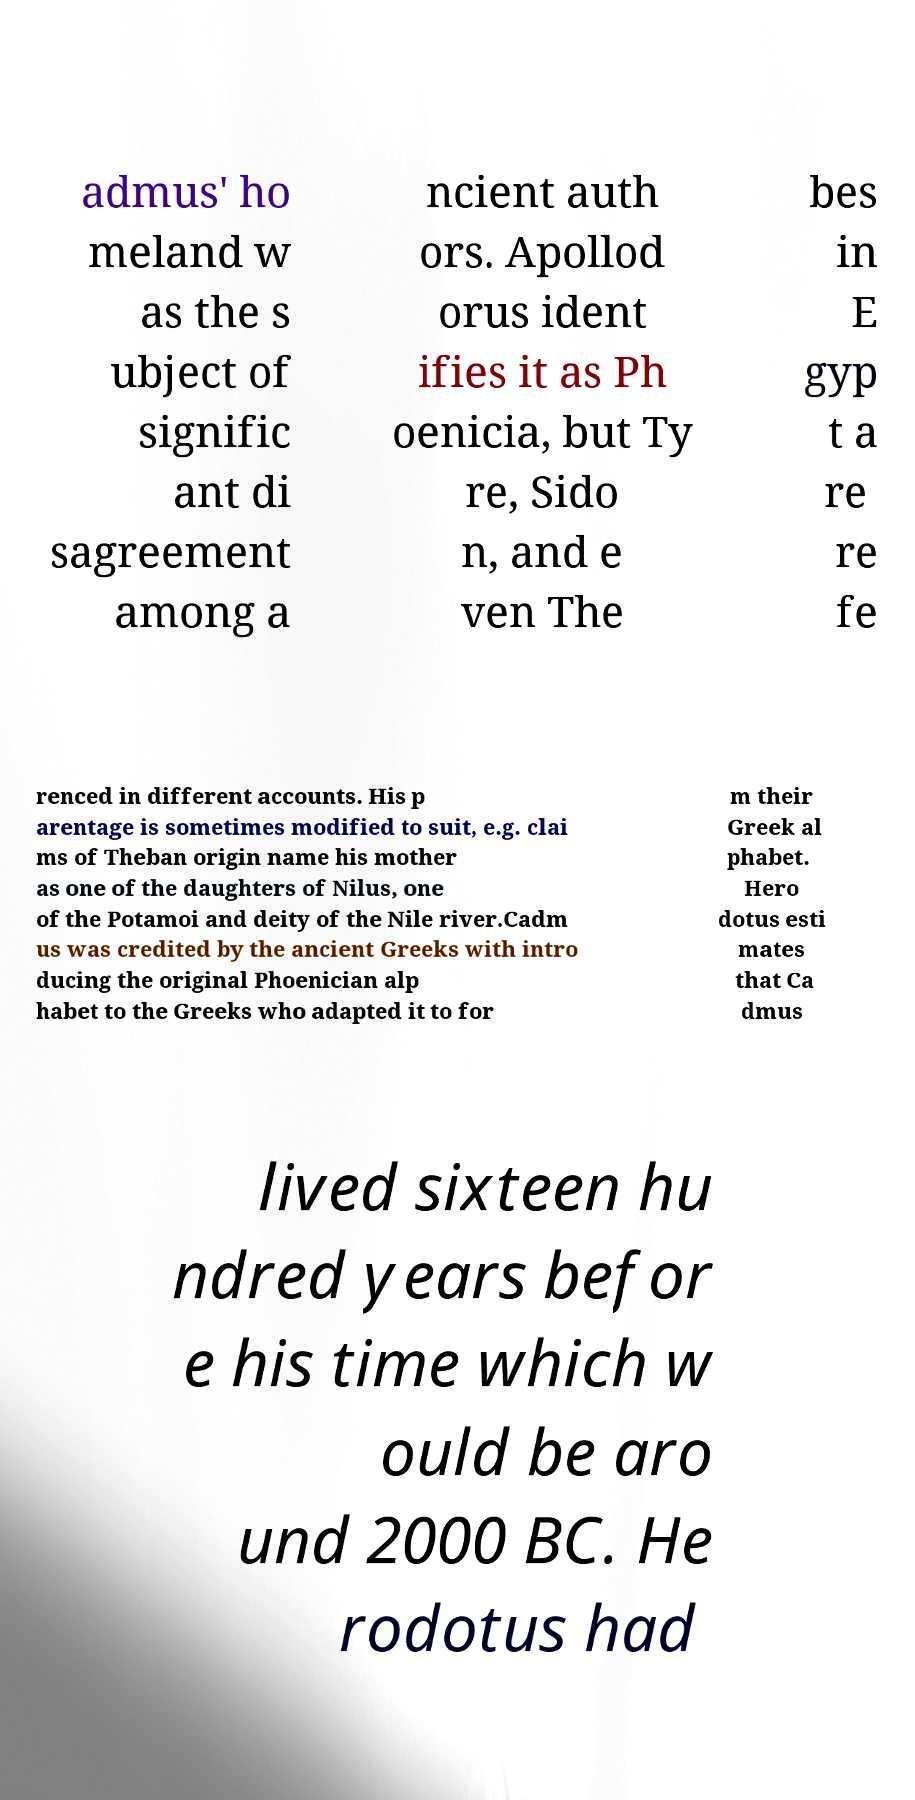Could you assist in decoding the text presented in this image and type it out clearly? admus' ho meland w as the s ubject of signific ant di sagreement among a ncient auth ors. Apollod orus ident ifies it as Ph oenicia, but Ty re, Sido n, and e ven The bes in E gyp t a re re fe renced in different accounts. His p arentage is sometimes modified to suit, e.g. clai ms of Theban origin name his mother as one of the daughters of Nilus, one of the Potamoi and deity of the Nile river.Cadm us was credited by the ancient Greeks with intro ducing the original Phoenician alp habet to the Greeks who adapted it to for m their Greek al phabet. Hero dotus esti mates that Ca dmus lived sixteen hu ndred years befor e his time which w ould be aro und 2000 BC. He rodotus had 